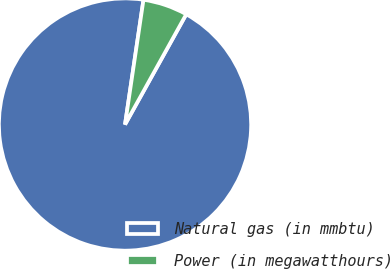Convert chart. <chart><loc_0><loc_0><loc_500><loc_500><pie_chart><fcel>Natural gas (in mmbtu)<fcel>Power (in megawatthours)<nl><fcel>94.27%<fcel>5.73%<nl></chart> 